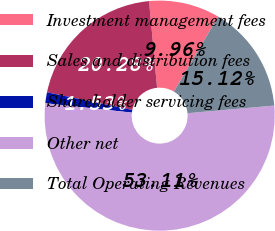Convert chart to OTSL. <chart><loc_0><loc_0><loc_500><loc_500><pie_chart><fcel>Investment management fees<fcel>Sales and distribution fees<fcel>Shareholder servicing fees<fcel>Other net<fcel>Total Operating Revenues<nl><fcel>9.96%<fcel>20.28%<fcel>1.53%<fcel>53.12%<fcel>15.12%<nl></chart> 